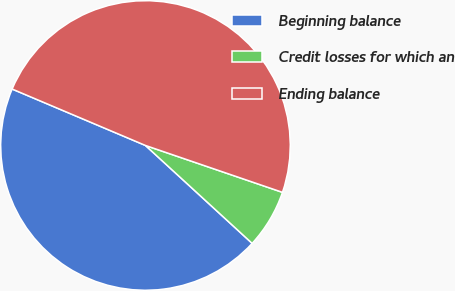Convert chart. <chart><loc_0><loc_0><loc_500><loc_500><pie_chart><fcel>Beginning balance<fcel>Credit losses for which an<fcel>Ending balance<nl><fcel>44.55%<fcel>6.57%<fcel>48.87%<nl></chart> 